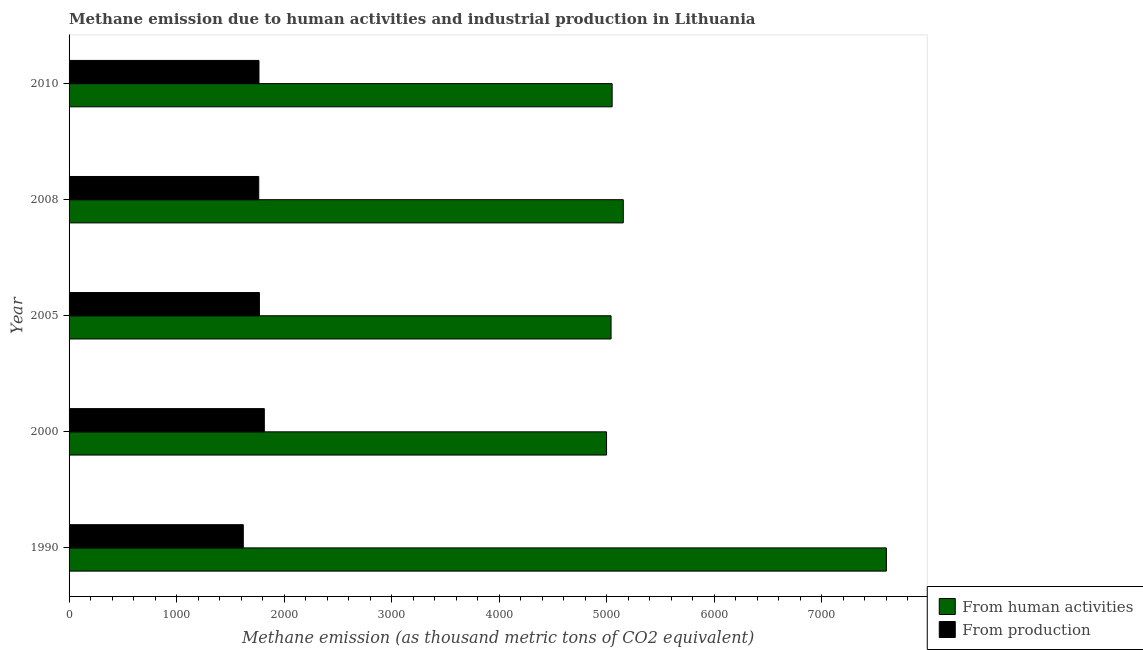How many groups of bars are there?
Make the answer very short. 5. Are the number of bars per tick equal to the number of legend labels?
Your answer should be very brief. Yes. Are the number of bars on each tick of the Y-axis equal?
Your answer should be compact. Yes. How many bars are there on the 4th tick from the bottom?
Give a very brief answer. 2. What is the amount of emissions generated from industries in 2000?
Ensure brevity in your answer.  1816.5. Across all years, what is the maximum amount of emissions generated from industries?
Your answer should be very brief. 1816.5. Across all years, what is the minimum amount of emissions from human activities?
Make the answer very short. 5000.2. In which year was the amount of emissions generated from industries minimum?
Your answer should be very brief. 1990. What is the total amount of emissions generated from industries in the graph?
Ensure brevity in your answer.  8739.6. What is the difference between the amount of emissions from human activities in 2000 and that in 2008?
Offer a very short reply. -155.6. What is the difference between the amount of emissions generated from industries in 2010 and the amount of emissions from human activities in 1990?
Keep it short and to the point. -5836.9. What is the average amount of emissions generated from industries per year?
Give a very brief answer. 1747.92. In the year 2008, what is the difference between the amount of emissions from human activities and amount of emissions generated from industries?
Make the answer very short. 3391.2. In how many years, is the amount of emissions from human activities greater than 5400 thousand metric tons?
Give a very brief answer. 1. What is the ratio of the amount of emissions from human activities in 1990 to that in 2005?
Your answer should be very brief. 1.51. Is the amount of emissions generated from industries in 1990 less than that in 2010?
Offer a very short reply. Yes. Is the difference between the amount of emissions generated from industries in 1990 and 2010 greater than the difference between the amount of emissions from human activities in 1990 and 2010?
Offer a very short reply. No. What is the difference between the highest and the second highest amount of emissions from human activities?
Your answer should be compact. 2447.8. What is the difference between the highest and the lowest amount of emissions generated from industries?
Your answer should be compact. 195.6. In how many years, is the amount of emissions generated from industries greater than the average amount of emissions generated from industries taken over all years?
Ensure brevity in your answer.  4. What does the 2nd bar from the top in 2005 represents?
Your response must be concise. From human activities. What does the 1st bar from the bottom in 2000 represents?
Keep it short and to the point. From human activities. Does the graph contain any zero values?
Ensure brevity in your answer.  No. Does the graph contain grids?
Provide a succinct answer. No. Where does the legend appear in the graph?
Keep it short and to the point. Bottom right. How many legend labels are there?
Offer a terse response. 2. How are the legend labels stacked?
Provide a short and direct response. Vertical. What is the title of the graph?
Keep it short and to the point. Methane emission due to human activities and industrial production in Lithuania. What is the label or title of the X-axis?
Make the answer very short. Methane emission (as thousand metric tons of CO2 equivalent). What is the Methane emission (as thousand metric tons of CO2 equivalent) in From human activities in 1990?
Your answer should be compact. 7603.6. What is the Methane emission (as thousand metric tons of CO2 equivalent) in From production in 1990?
Your answer should be very brief. 1620.9. What is the Methane emission (as thousand metric tons of CO2 equivalent) of From human activities in 2000?
Your answer should be very brief. 5000.2. What is the Methane emission (as thousand metric tons of CO2 equivalent) of From production in 2000?
Give a very brief answer. 1816.5. What is the Methane emission (as thousand metric tons of CO2 equivalent) in From human activities in 2005?
Provide a succinct answer. 5042.2. What is the Methane emission (as thousand metric tons of CO2 equivalent) of From production in 2005?
Make the answer very short. 1770.9. What is the Methane emission (as thousand metric tons of CO2 equivalent) of From human activities in 2008?
Offer a terse response. 5155.8. What is the Methane emission (as thousand metric tons of CO2 equivalent) in From production in 2008?
Provide a succinct answer. 1764.6. What is the Methane emission (as thousand metric tons of CO2 equivalent) in From human activities in 2010?
Offer a very short reply. 5052.2. What is the Methane emission (as thousand metric tons of CO2 equivalent) in From production in 2010?
Provide a succinct answer. 1766.7. Across all years, what is the maximum Methane emission (as thousand metric tons of CO2 equivalent) in From human activities?
Your answer should be very brief. 7603.6. Across all years, what is the maximum Methane emission (as thousand metric tons of CO2 equivalent) in From production?
Make the answer very short. 1816.5. Across all years, what is the minimum Methane emission (as thousand metric tons of CO2 equivalent) in From human activities?
Your answer should be very brief. 5000.2. Across all years, what is the minimum Methane emission (as thousand metric tons of CO2 equivalent) of From production?
Keep it short and to the point. 1620.9. What is the total Methane emission (as thousand metric tons of CO2 equivalent) of From human activities in the graph?
Keep it short and to the point. 2.79e+04. What is the total Methane emission (as thousand metric tons of CO2 equivalent) of From production in the graph?
Your response must be concise. 8739.6. What is the difference between the Methane emission (as thousand metric tons of CO2 equivalent) of From human activities in 1990 and that in 2000?
Give a very brief answer. 2603.4. What is the difference between the Methane emission (as thousand metric tons of CO2 equivalent) of From production in 1990 and that in 2000?
Keep it short and to the point. -195.6. What is the difference between the Methane emission (as thousand metric tons of CO2 equivalent) in From human activities in 1990 and that in 2005?
Your response must be concise. 2561.4. What is the difference between the Methane emission (as thousand metric tons of CO2 equivalent) in From production in 1990 and that in 2005?
Provide a short and direct response. -150. What is the difference between the Methane emission (as thousand metric tons of CO2 equivalent) in From human activities in 1990 and that in 2008?
Make the answer very short. 2447.8. What is the difference between the Methane emission (as thousand metric tons of CO2 equivalent) in From production in 1990 and that in 2008?
Make the answer very short. -143.7. What is the difference between the Methane emission (as thousand metric tons of CO2 equivalent) in From human activities in 1990 and that in 2010?
Offer a terse response. 2551.4. What is the difference between the Methane emission (as thousand metric tons of CO2 equivalent) of From production in 1990 and that in 2010?
Offer a terse response. -145.8. What is the difference between the Methane emission (as thousand metric tons of CO2 equivalent) in From human activities in 2000 and that in 2005?
Your answer should be compact. -42. What is the difference between the Methane emission (as thousand metric tons of CO2 equivalent) of From production in 2000 and that in 2005?
Offer a very short reply. 45.6. What is the difference between the Methane emission (as thousand metric tons of CO2 equivalent) of From human activities in 2000 and that in 2008?
Your response must be concise. -155.6. What is the difference between the Methane emission (as thousand metric tons of CO2 equivalent) in From production in 2000 and that in 2008?
Your response must be concise. 51.9. What is the difference between the Methane emission (as thousand metric tons of CO2 equivalent) of From human activities in 2000 and that in 2010?
Make the answer very short. -52. What is the difference between the Methane emission (as thousand metric tons of CO2 equivalent) of From production in 2000 and that in 2010?
Make the answer very short. 49.8. What is the difference between the Methane emission (as thousand metric tons of CO2 equivalent) in From human activities in 2005 and that in 2008?
Your answer should be compact. -113.6. What is the difference between the Methane emission (as thousand metric tons of CO2 equivalent) of From production in 2005 and that in 2008?
Your answer should be very brief. 6.3. What is the difference between the Methane emission (as thousand metric tons of CO2 equivalent) in From human activities in 2008 and that in 2010?
Provide a short and direct response. 103.6. What is the difference between the Methane emission (as thousand metric tons of CO2 equivalent) of From human activities in 1990 and the Methane emission (as thousand metric tons of CO2 equivalent) of From production in 2000?
Provide a short and direct response. 5787.1. What is the difference between the Methane emission (as thousand metric tons of CO2 equivalent) in From human activities in 1990 and the Methane emission (as thousand metric tons of CO2 equivalent) in From production in 2005?
Ensure brevity in your answer.  5832.7. What is the difference between the Methane emission (as thousand metric tons of CO2 equivalent) of From human activities in 1990 and the Methane emission (as thousand metric tons of CO2 equivalent) of From production in 2008?
Your answer should be compact. 5839. What is the difference between the Methane emission (as thousand metric tons of CO2 equivalent) of From human activities in 1990 and the Methane emission (as thousand metric tons of CO2 equivalent) of From production in 2010?
Provide a succinct answer. 5836.9. What is the difference between the Methane emission (as thousand metric tons of CO2 equivalent) in From human activities in 2000 and the Methane emission (as thousand metric tons of CO2 equivalent) in From production in 2005?
Offer a very short reply. 3229.3. What is the difference between the Methane emission (as thousand metric tons of CO2 equivalent) of From human activities in 2000 and the Methane emission (as thousand metric tons of CO2 equivalent) of From production in 2008?
Provide a succinct answer. 3235.6. What is the difference between the Methane emission (as thousand metric tons of CO2 equivalent) of From human activities in 2000 and the Methane emission (as thousand metric tons of CO2 equivalent) of From production in 2010?
Your answer should be compact. 3233.5. What is the difference between the Methane emission (as thousand metric tons of CO2 equivalent) in From human activities in 2005 and the Methane emission (as thousand metric tons of CO2 equivalent) in From production in 2008?
Provide a short and direct response. 3277.6. What is the difference between the Methane emission (as thousand metric tons of CO2 equivalent) in From human activities in 2005 and the Methane emission (as thousand metric tons of CO2 equivalent) in From production in 2010?
Keep it short and to the point. 3275.5. What is the difference between the Methane emission (as thousand metric tons of CO2 equivalent) in From human activities in 2008 and the Methane emission (as thousand metric tons of CO2 equivalent) in From production in 2010?
Your answer should be compact. 3389.1. What is the average Methane emission (as thousand metric tons of CO2 equivalent) of From human activities per year?
Your answer should be very brief. 5570.8. What is the average Methane emission (as thousand metric tons of CO2 equivalent) in From production per year?
Ensure brevity in your answer.  1747.92. In the year 1990, what is the difference between the Methane emission (as thousand metric tons of CO2 equivalent) in From human activities and Methane emission (as thousand metric tons of CO2 equivalent) in From production?
Your response must be concise. 5982.7. In the year 2000, what is the difference between the Methane emission (as thousand metric tons of CO2 equivalent) in From human activities and Methane emission (as thousand metric tons of CO2 equivalent) in From production?
Your response must be concise. 3183.7. In the year 2005, what is the difference between the Methane emission (as thousand metric tons of CO2 equivalent) in From human activities and Methane emission (as thousand metric tons of CO2 equivalent) in From production?
Ensure brevity in your answer.  3271.3. In the year 2008, what is the difference between the Methane emission (as thousand metric tons of CO2 equivalent) in From human activities and Methane emission (as thousand metric tons of CO2 equivalent) in From production?
Provide a succinct answer. 3391.2. In the year 2010, what is the difference between the Methane emission (as thousand metric tons of CO2 equivalent) of From human activities and Methane emission (as thousand metric tons of CO2 equivalent) of From production?
Keep it short and to the point. 3285.5. What is the ratio of the Methane emission (as thousand metric tons of CO2 equivalent) in From human activities in 1990 to that in 2000?
Your response must be concise. 1.52. What is the ratio of the Methane emission (as thousand metric tons of CO2 equivalent) of From production in 1990 to that in 2000?
Offer a terse response. 0.89. What is the ratio of the Methane emission (as thousand metric tons of CO2 equivalent) in From human activities in 1990 to that in 2005?
Give a very brief answer. 1.51. What is the ratio of the Methane emission (as thousand metric tons of CO2 equivalent) in From production in 1990 to that in 2005?
Your answer should be compact. 0.92. What is the ratio of the Methane emission (as thousand metric tons of CO2 equivalent) of From human activities in 1990 to that in 2008?
Offer a very short reply. 1.47. What is the ratio of the Methane emission (as thousand metric tons of CO2 equivalent) in From production in 1990 to that in 2008?
Offer a very short reply. 0.92. What is the ratio of the Methane emission (as thousand metric tons of CO2 equivalent) in From human activities in 1990 to that in 2010?
Keep it short and to the point. 1.5. What is the ratio of the Methane emission (as thousand metric tons of CO2 equivalent) of From production in 1990 to that in 2010?
Your answer should be compact. 0.92. What is the ratio of the Methane emission (as thousand metric tons of CO2 equivalent) of From production in 2000 to that in 2005?
Provide a succinct answer. 1.03. What is the ratio of the Methane emission (as thousand metric tons of CO2 equivalent) of From human activities in 2000 to that in 2008?
Offer a very short reply. 0.97. What is the ratio of the Methane emission (as thousand metric tons of CO2 equivalent) of From production in 2000 to that in 2008?
Your answer should be compact. 1.03. What is the ratio of the Methane emission (as thousand metric tons of CO2 equivalent) in From human activities in 2000 to that in 2010?
Ensure brevity in your answer.  0.99. What is the ratio of the Methane emission (as thousand metric tons of CO2 equivalent) in From production in 2000 to that in 2010?
Ensure brevity in your answer.  1.03. What is the ratio of the Methane emission (as thousand metric tons of CO2 equivalent) of From human activities in 2005 to that in 2008?
Keep it short and to the point. 0.98. What is the ratio of the Methane emission (as thousand metric tons of CO2 equivalent) in From production in 2005 to that in 2008?
Offer a very short reply. 1. What is the ratio of the Methane emission (as thousand metric tons of CO2 equivalent) in From human activities in 2005 to that in 2010?
Ensure brevity in your answer.  1. What is the ratio of the Methane emission (as thousand metric tons of CO2 equivalent) in From production in 2005 to that in 2010?
Your answer should be compact. 1. What is the ratio of the Methane emission (as thousand metric tons of CO2 equivalent) in From human activities in 2008 to that in 2010?
Your response must be concise. 1.02. What is the difference between the highest and the second highest Methane emission (as thousand metric tons of CO2 equivalent) in From human activities?
Keep it short and to the point. 2447.8. What is the difference between the highest and the second highest Methane emission (as thousand metric tons of CO2 equivalent) of From production?
Keep it short and to the point. 45.6. What is the difference between the highest and the lowest Methane emission (as thousand metric tons of CO2 equivalent) in From human activities?
Ensure brevity in your answer.  2603.4. What is the difference between the highest and the lowest Methane emission (as thousand metric tons of CO2 equivalent) of From production?
Provide a short and direct response. 195.6. 